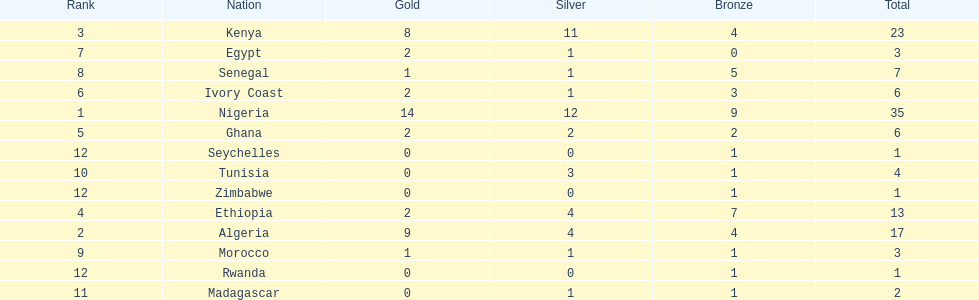What is the name of the only nation that did not earn any bronze medals? Egypt. 